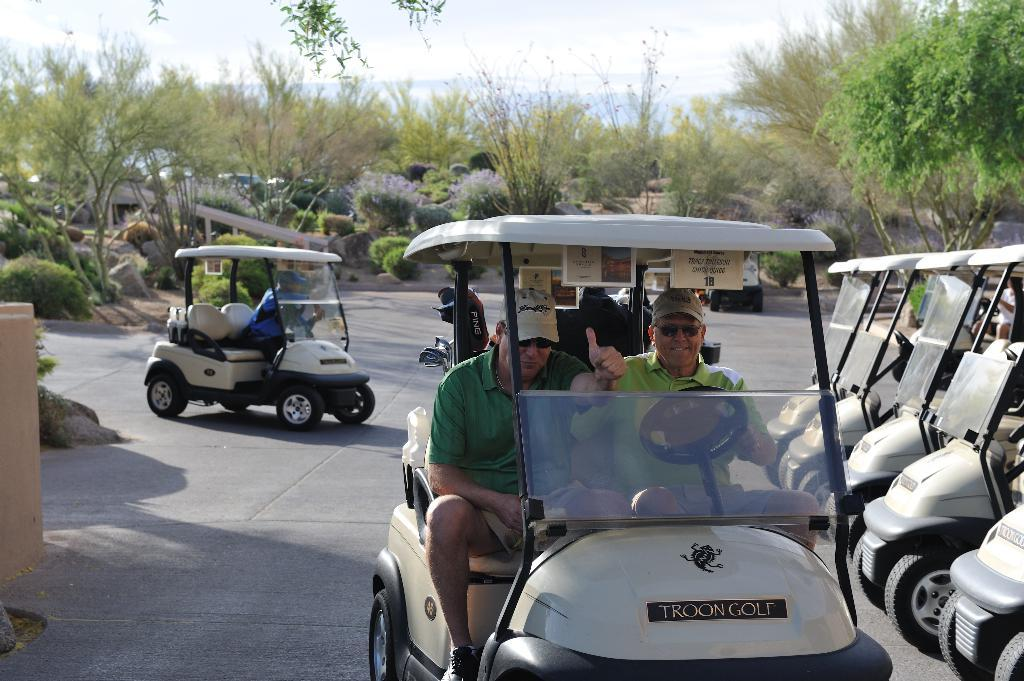How many people are in the image? There are two men in the image. What are the men doing in the image? The men are sitting in a vehicle. What else can be seen in the image besides the men and the vehicle they are in? There are other vehicles and a tree in the image. How long does it take for the impulse to travel through the tree in the image? There is no impulse or measurement of time mentioned in the image, as it only features two men sitting in a vehicle, other vehicles, and a tree. 